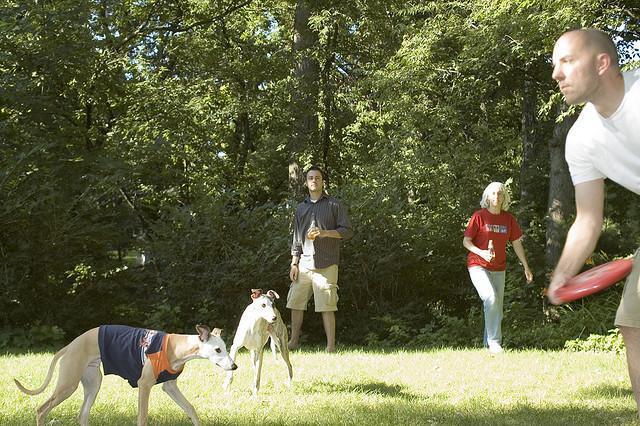How many people are in the picture?
Give a very brief answer. 3. How many dogs are there?
Give a very brief answer. 2. 